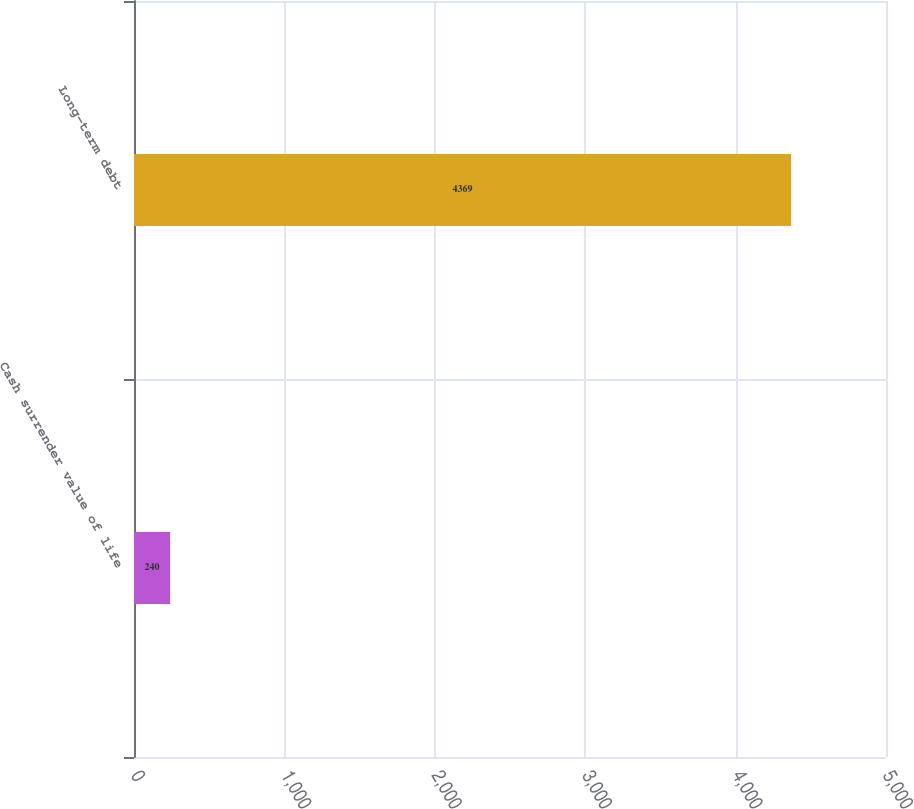<chart> <loc_0><loc_0><loc_500><loc_500><bar_chart><fcel>Cash surrender value of life<fcel>Long-term debt<nl><fcel>240<fcel>4369<nl></chart> 